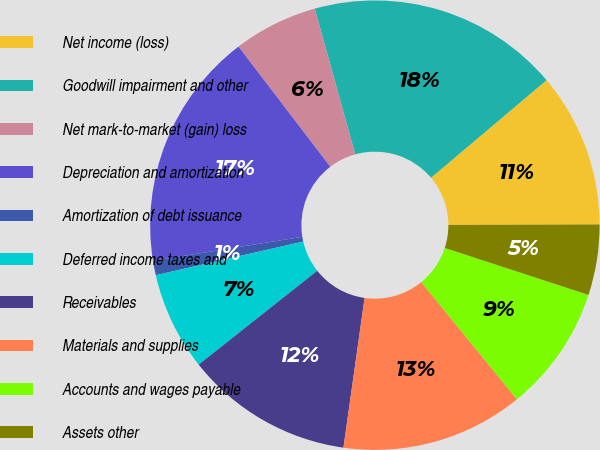<chart> <loc_0><loc_0><loc_500><loc_500><pie_chart><fcel>Net income (loss)<fcel>Goodwill impairment and other<fcel>Net mark-to-market (gain) loss<fcel>Depreciation and amortization<fcel>Amortization of debt issuance<fcel>Deferred income taxes and<fcel>Receivables<fcel>Materials and supplies<fcel>Accounts and wages payable<fcel>Assets other<nl><fcel>11.11%<fcel>18.15%<fcel>6.07%<fcel>17.15%<fcel>1.04%<fcel>7.08%<fcel>12.11%<fcel>13.12%<fcel>9.09%<fcel>5.07%<nl></chart> 